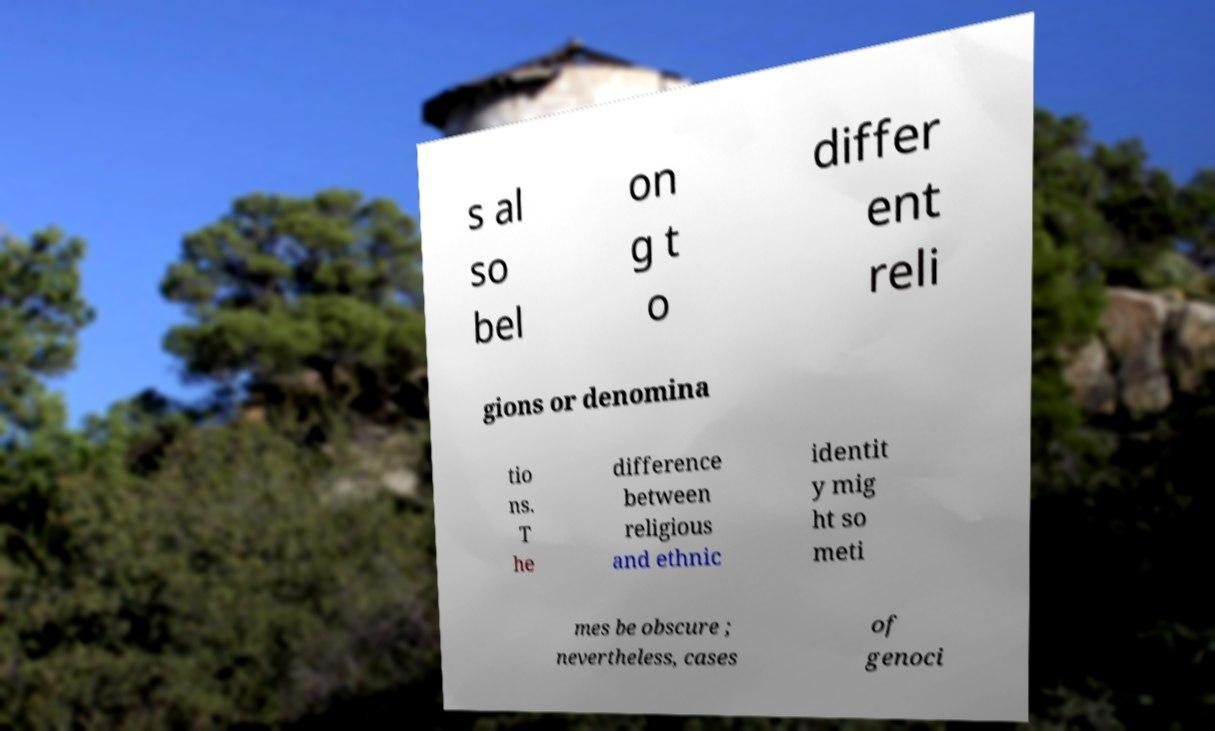Please read and relay the text visible in this image. What does it say? s al so bel on g t o differ ent reli gions or denomina tio ns. T he difference between religious and ethnic identit y mig ht so meti mes be obscure ; nevertheless, cases of genoci 